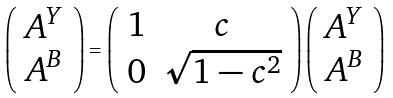Convert formula to latex. <formula><loc_0><loc_0><loc_500><loc_500>\left ( \begin{array} { c } { { A ^ { Y } } } \\ { { A ^ { B } } } \end{array} \right ) = \left ( \begin{array} { c c } { 1 } & { c } \\ { 0 } & { { \sqrt { 1 - c ^ { 2 } } } } \end{array} \right ) \left ( \begin{array} { c } { { A ^ { Y } } } \\ { { A ^ { B } } } \end{array} \right )</formula> 